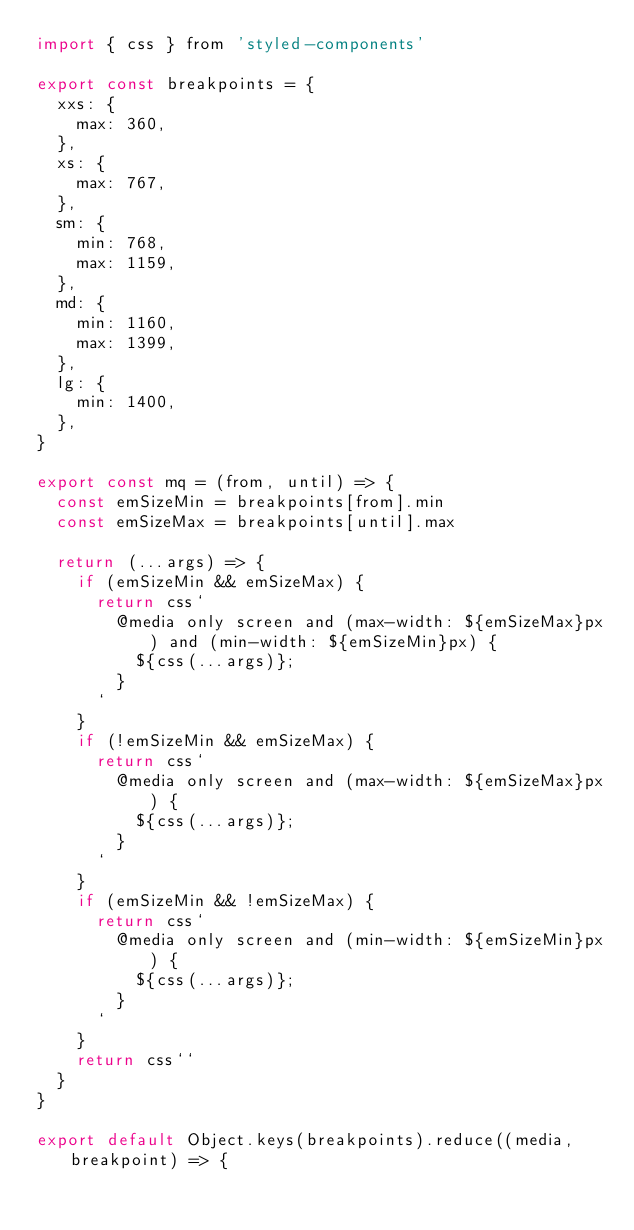Convert code to text. <code><loc_0><loc_0><loc_500><loc_500><_JavaScript_>import { css } from 'styled-components'

export const breakpoints = {
  xxs: {
    max: 360,
  },
  xs: {
    max: 767,
  },
  sm: {
    min: 768,
    max: 1159,
  },
  md: {
    min: 1160,
    max: 1399,
  },
  lg: {
    min: 1400,
  },
}

export const mq = (from, until) => {
  const emSizeMin = breakpoints[from].min
  const emSizeMax = breakpoints[until].max

  return (...args) => {
    if (emSizeMin && emSizeMax) {
      return css`
        @media only screen and (max-width: ${emSizeMax}px) and (min-width: ${emSizeMin}px) {
          ${css(...args)};
        }
      `
    }
    if (!emSizeMin && emSizeMax) {
      return css`
        @media only screen and (max-width: ${emSizeMax}px) {
          ${css(...args)};
        }
      `
    }
    if (emSizeMin && !emSizeMax) {
      return css`
        @media only screen and (min-width: ${emSizeMin}px) {
          ${css(...args)};
        }
      `
    }
    return css``
  }
}

export default Object.keys(breakpoints).reduce((media, breakpoint) => {</code> 